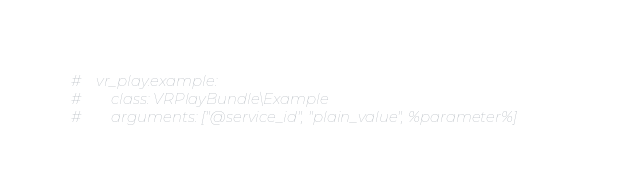<code> <loc_0><loc_0><loc_500><loc_500><_YAML_>#    vr_play.example:
#        class: VRPlayBundle\Example
#        arguments: ["@service_id", "plain_value", %parameter%]
</code> 